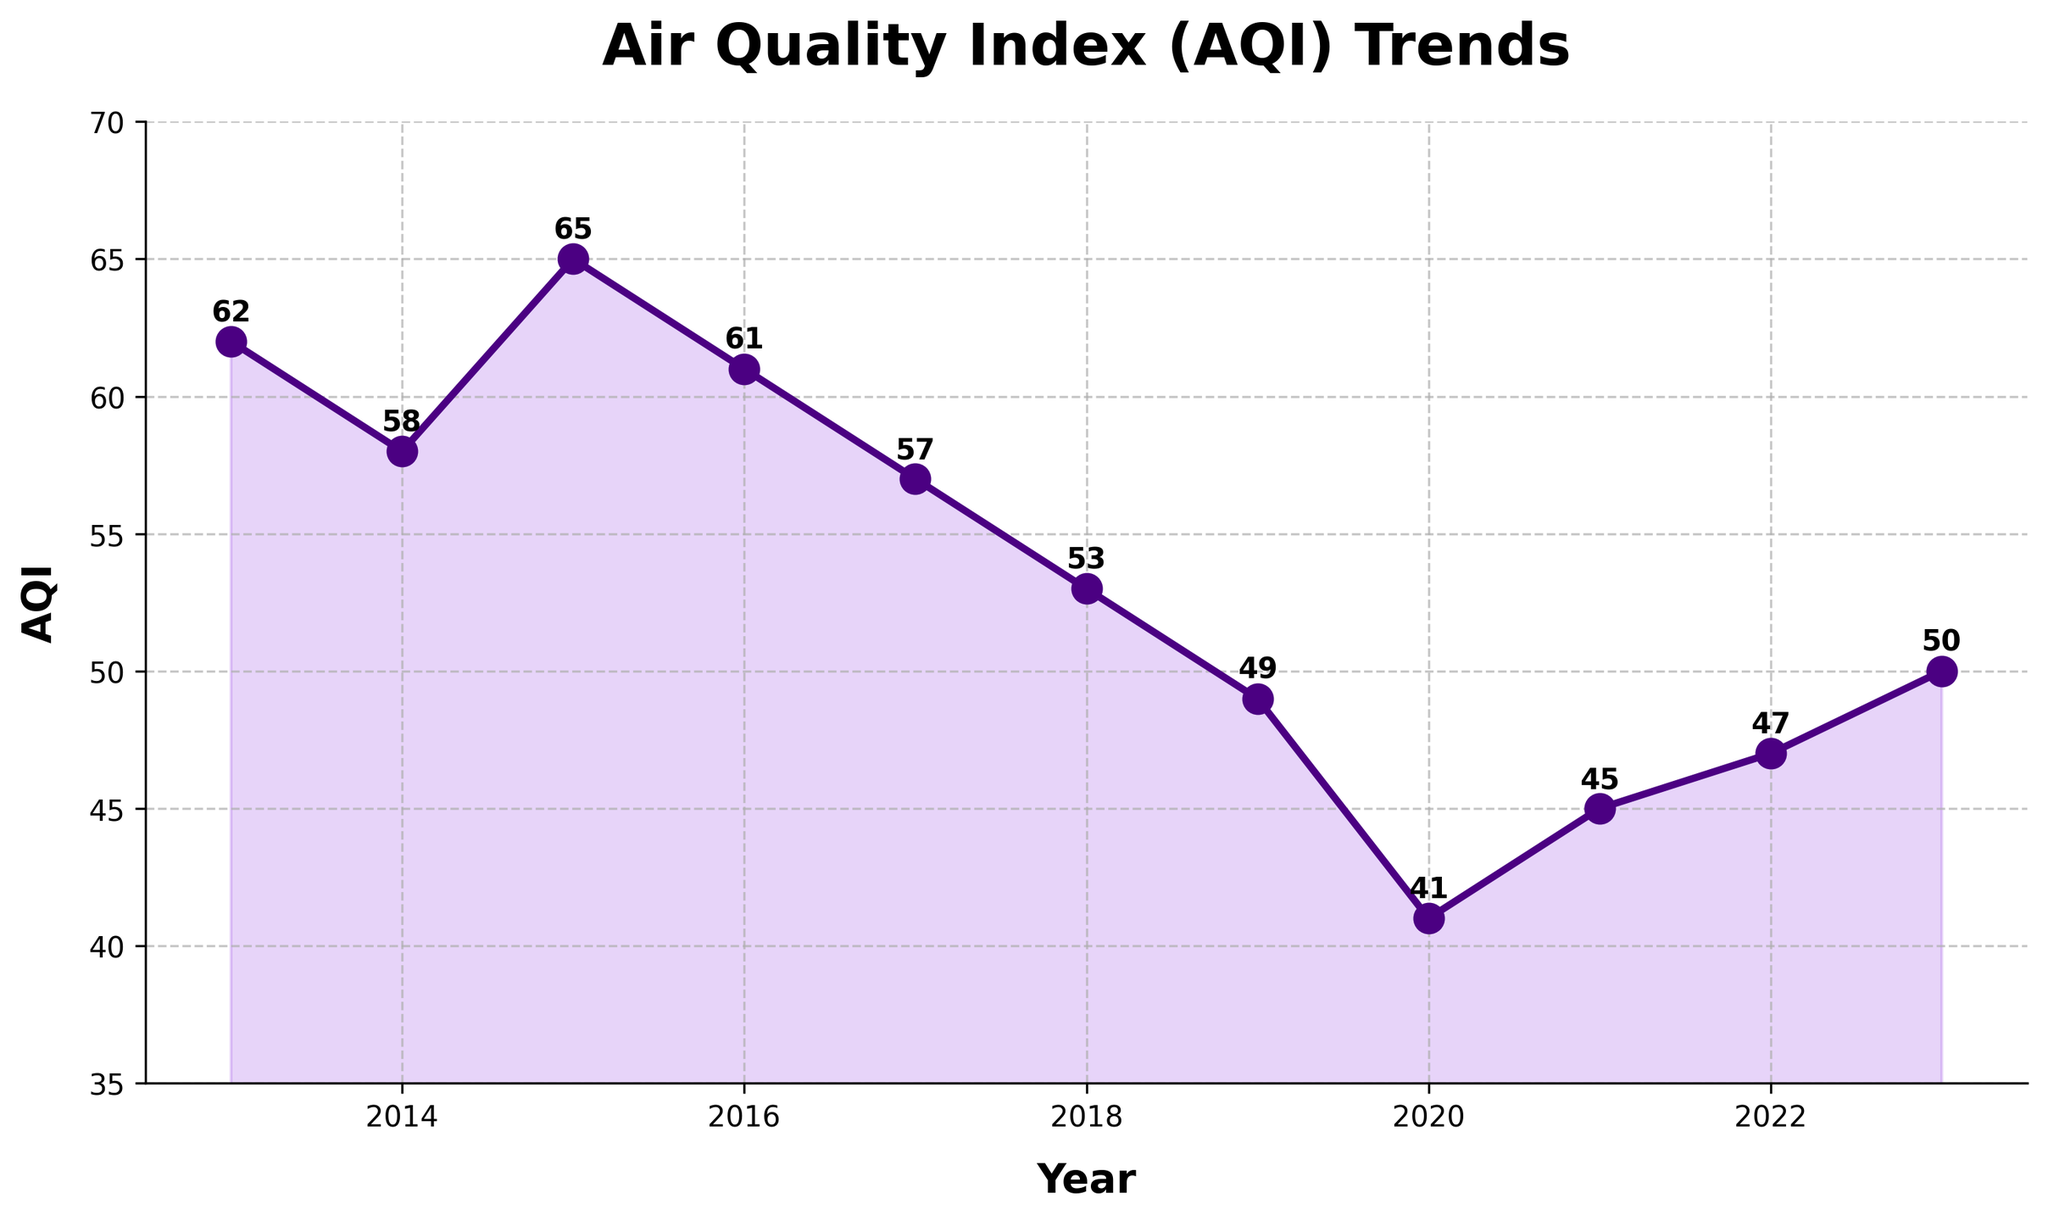What year had the lowest AQI level? Look at the points on the line chart and identify the lowest point on the y-axis. The lowest point corresponds to the AQI level of 41 in 2020.
Answer: 2020 How did the AQI level in 2021 compare to that in 2020? Compare the AQI levels for the years 2020 and 2021. The AQI level in 2021 (45) is higher than in 2020 (41).
Answer: Higher Which two consecutive years had the largest decrease in AQI levels? Look at the AQI levels from year to year and calculate the differences. The largest decrease is from 2018 (53) to 2019 (49), a drop of 4 points.
Answer: 2018 to 2019 What is the average AQI level over the past decade? Sum up all the AQI values and divide by the number of years. (62+58+65+61+57+53+49+41+45+47+50)/11=53.27
Answer: 53.27 What is the general trend in AQI levels from 2013 to 2023? Observe the overall direction of the line plot. There is a general decrease in AQI levels over the years, indicating improving air quality.
Answer: Decreasing Is there any year where the AQI level stayed the same as the previous year? Check the AQI values year by year to see if any years have the same value. None of the years have the same AQI level as the previous year.
Answer: No What was the AQI level in 2017, and how does it compare to 2023? Look at the AQI levels for 2017 and 2023. In 2017, the AQI was 57, and in 2023, it was 50. The AQI level in 2017 was higher than in 2023.
Answer: Higher in 2017 What is the range of AQI levels from 2013 to 2023? Identify the highest and lowest AQI levels and calculate the difference. The highest AQI is 65 (2015), and the lowest is 41 (2020), so the range is 65-41=24.
Answer: 24 Which year saw the highest AQI level, and what was it? Identify the highest point on the line chart. The highest AQI level was 65 in 2015.
Answer: 2015 By how much did the AQI level change from 2015 to 2016? Subtract the AQI level in 2016 from that in 2015. The AQI level in 2015 was 65 and in 2016 was 61, so the change is 65-61=4.
Answer: 4 (decrease) 